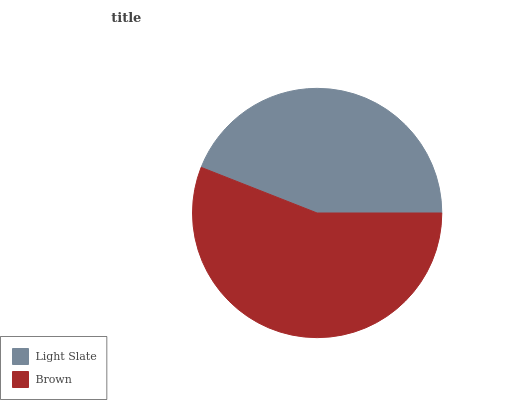Is Light Slate the minimum?
Answer yes or no. Yes. Is Brown the maximum?
Answer yes or no. Yes. Is Brown the minimum?
Answer yes or no. No. Is Brown greater than Light Slate?
Answer yes or no. Yes. Is Light Slate less than Brown?
Answer yes or no. Yes. Is Light Slate greater than Brown?
Answer yes or no. No. Is Brown less than Light Slate?
Answer yes or no. No. Is Brown the high median?
Answer yes or no. Yes. Is Light Slate the low median?
Answer yes or no. Yes. Is Light Slate the high median?
Answer yes or no. No. Is Brown the low median?
Answer yes or no. No. 